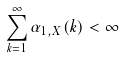<formula> <loc_0><loc_0><loc_500><loc_500>\sum _ { k = 1 } ^ { \infty } \alpha _ { 1 , { X } } ( k ) < \infty</formula> 